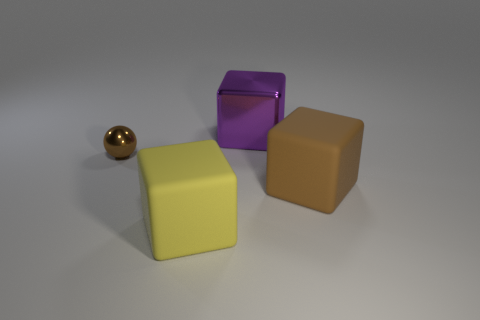Add 1 large brown rubber cylinders. How many objects exist? 5 Subtract all blocks. How many objects are left? 1 Add 1 shiny spheres. How many shiny spheres exist? 2 Subtract 0 purple cylinders. How many objects are left? 4 Subtract all tiny brown metallic things. Subtract all metal things. How many objects are left? 1 Add 3 brown cubes. How many brown cubes are left? 4 